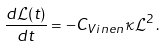<formula> <loc_0><loc_0><loc_500><loc_500>\, \frac { d \mathcal { L } ( t ) } { d t } = - C _ { V i n e n } \kappa \mathcal { L } ^ { 2 } \, . \,</formula> 